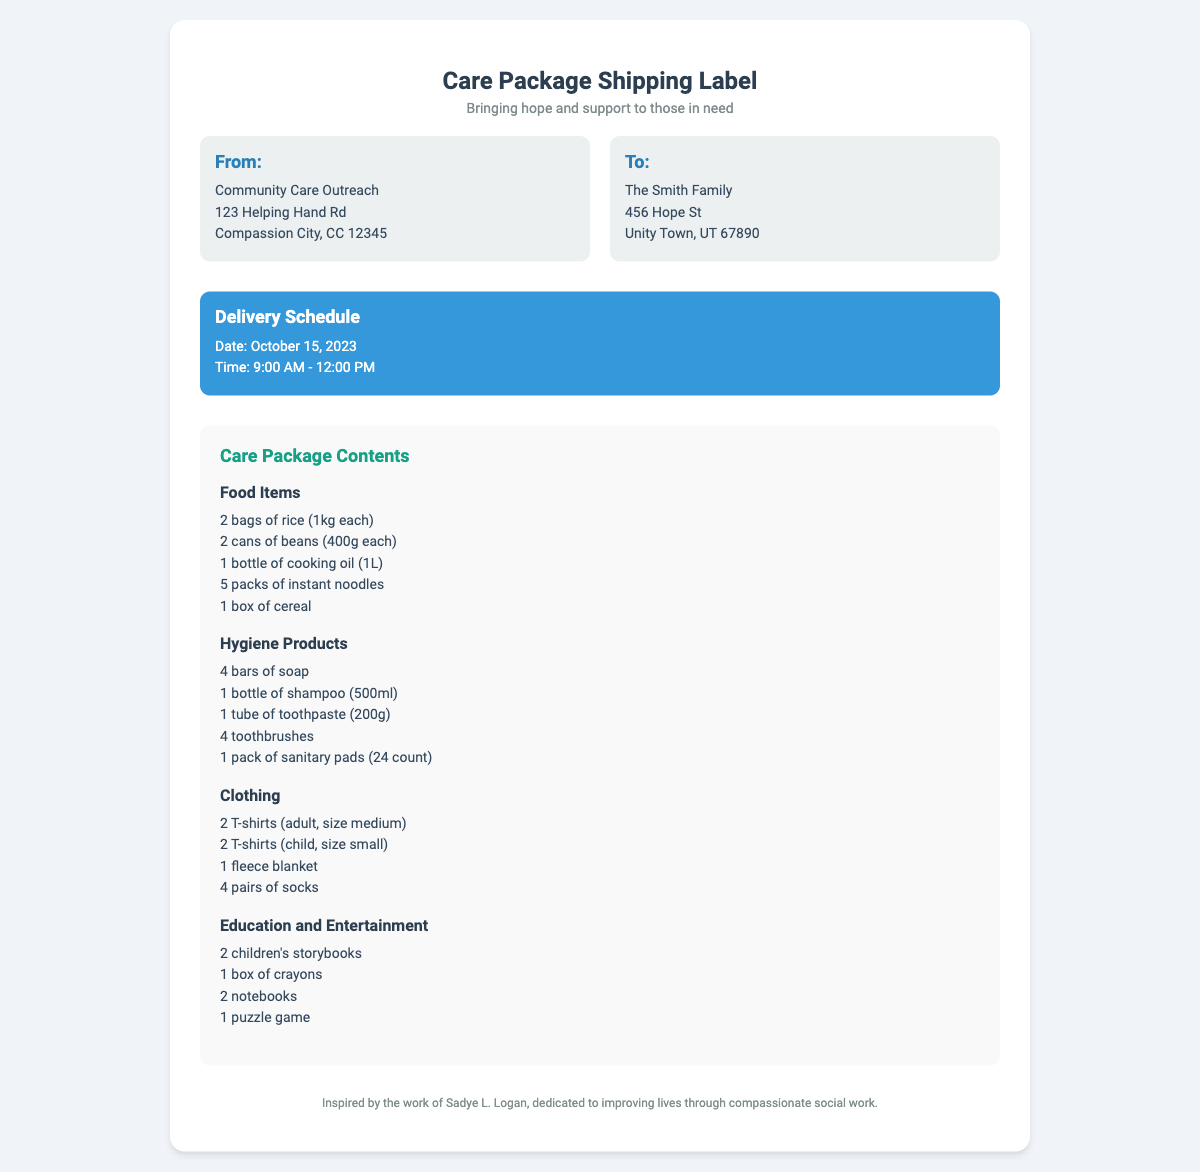what is the delivery date? The delivery date is clearly stated in the document under the delivery schedule section.
Answer: October 15, 2023 who is the recipient of the care package? The recipient's name and address are provided in the address section of the shipping label.
Answer: The Smith Family how many bags of rice are included in the care package? The number of bags of rice is specified in the contents section under food items.
Answer: 2 bags what is the size of the adult T-shirts? The size of the adult T-shirts is mentioned under the clothing section of the contents.
Answer: size medium what does the delivery schedule indicate about the delivery time? The delivery time is provided alongside the date in the delivery schedule section.
Answer: 9:00 AM - 12:00 PM how many children's storybooks are included? The quantity of children's storybooks is listed in the education and entertainment section of the contents.
Answer: 2 children's storybooks which organization is sending the care package? The sender's organization is mentioned at the top of the address section of the document.
Answer: Community Care Outreach what type of hygiene product is included in the package? The category of hygiene products is specified in the contents section, listing different items included.
Answer: soap 